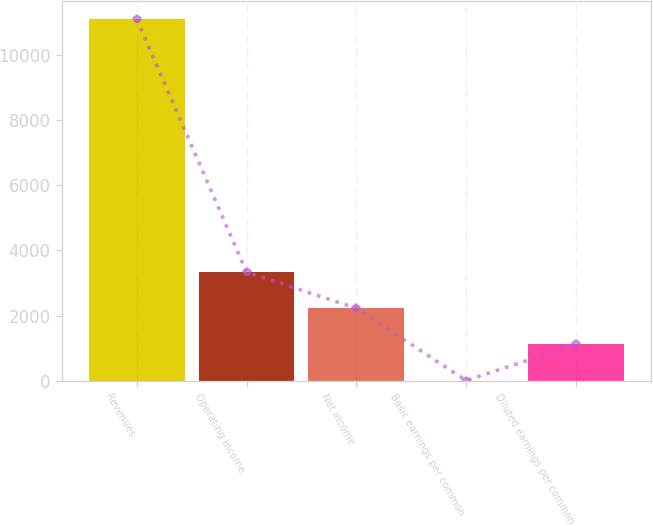Convert chart. <chart><loc_0><loc_0><loc_500><loc_500><bar_chart><fcel>Revenues<fcel>Operating income<fcel>Net income<fcel>Basic earnings per common<fcel>Diluted earnings per common<nl><fcel>11107<fcel>3333.07<fcel>2222.51<fcel>1.39<fcel>1111.95<nl></chart> 